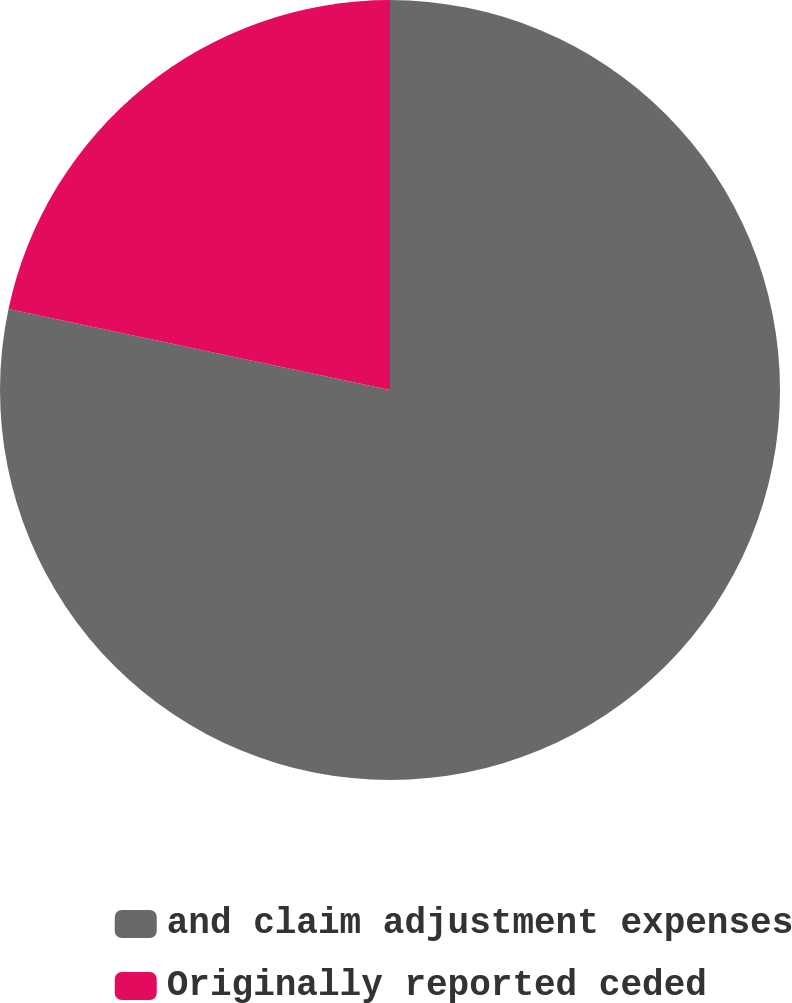<chart> <loc_0><loc_0><loc_500><loc_500><pie_chart><fcel>and claim adjustment expenses<fcel>Originally reported ceded<nl><fcel>78.33%<fcel>21.67%<nl></chart> 